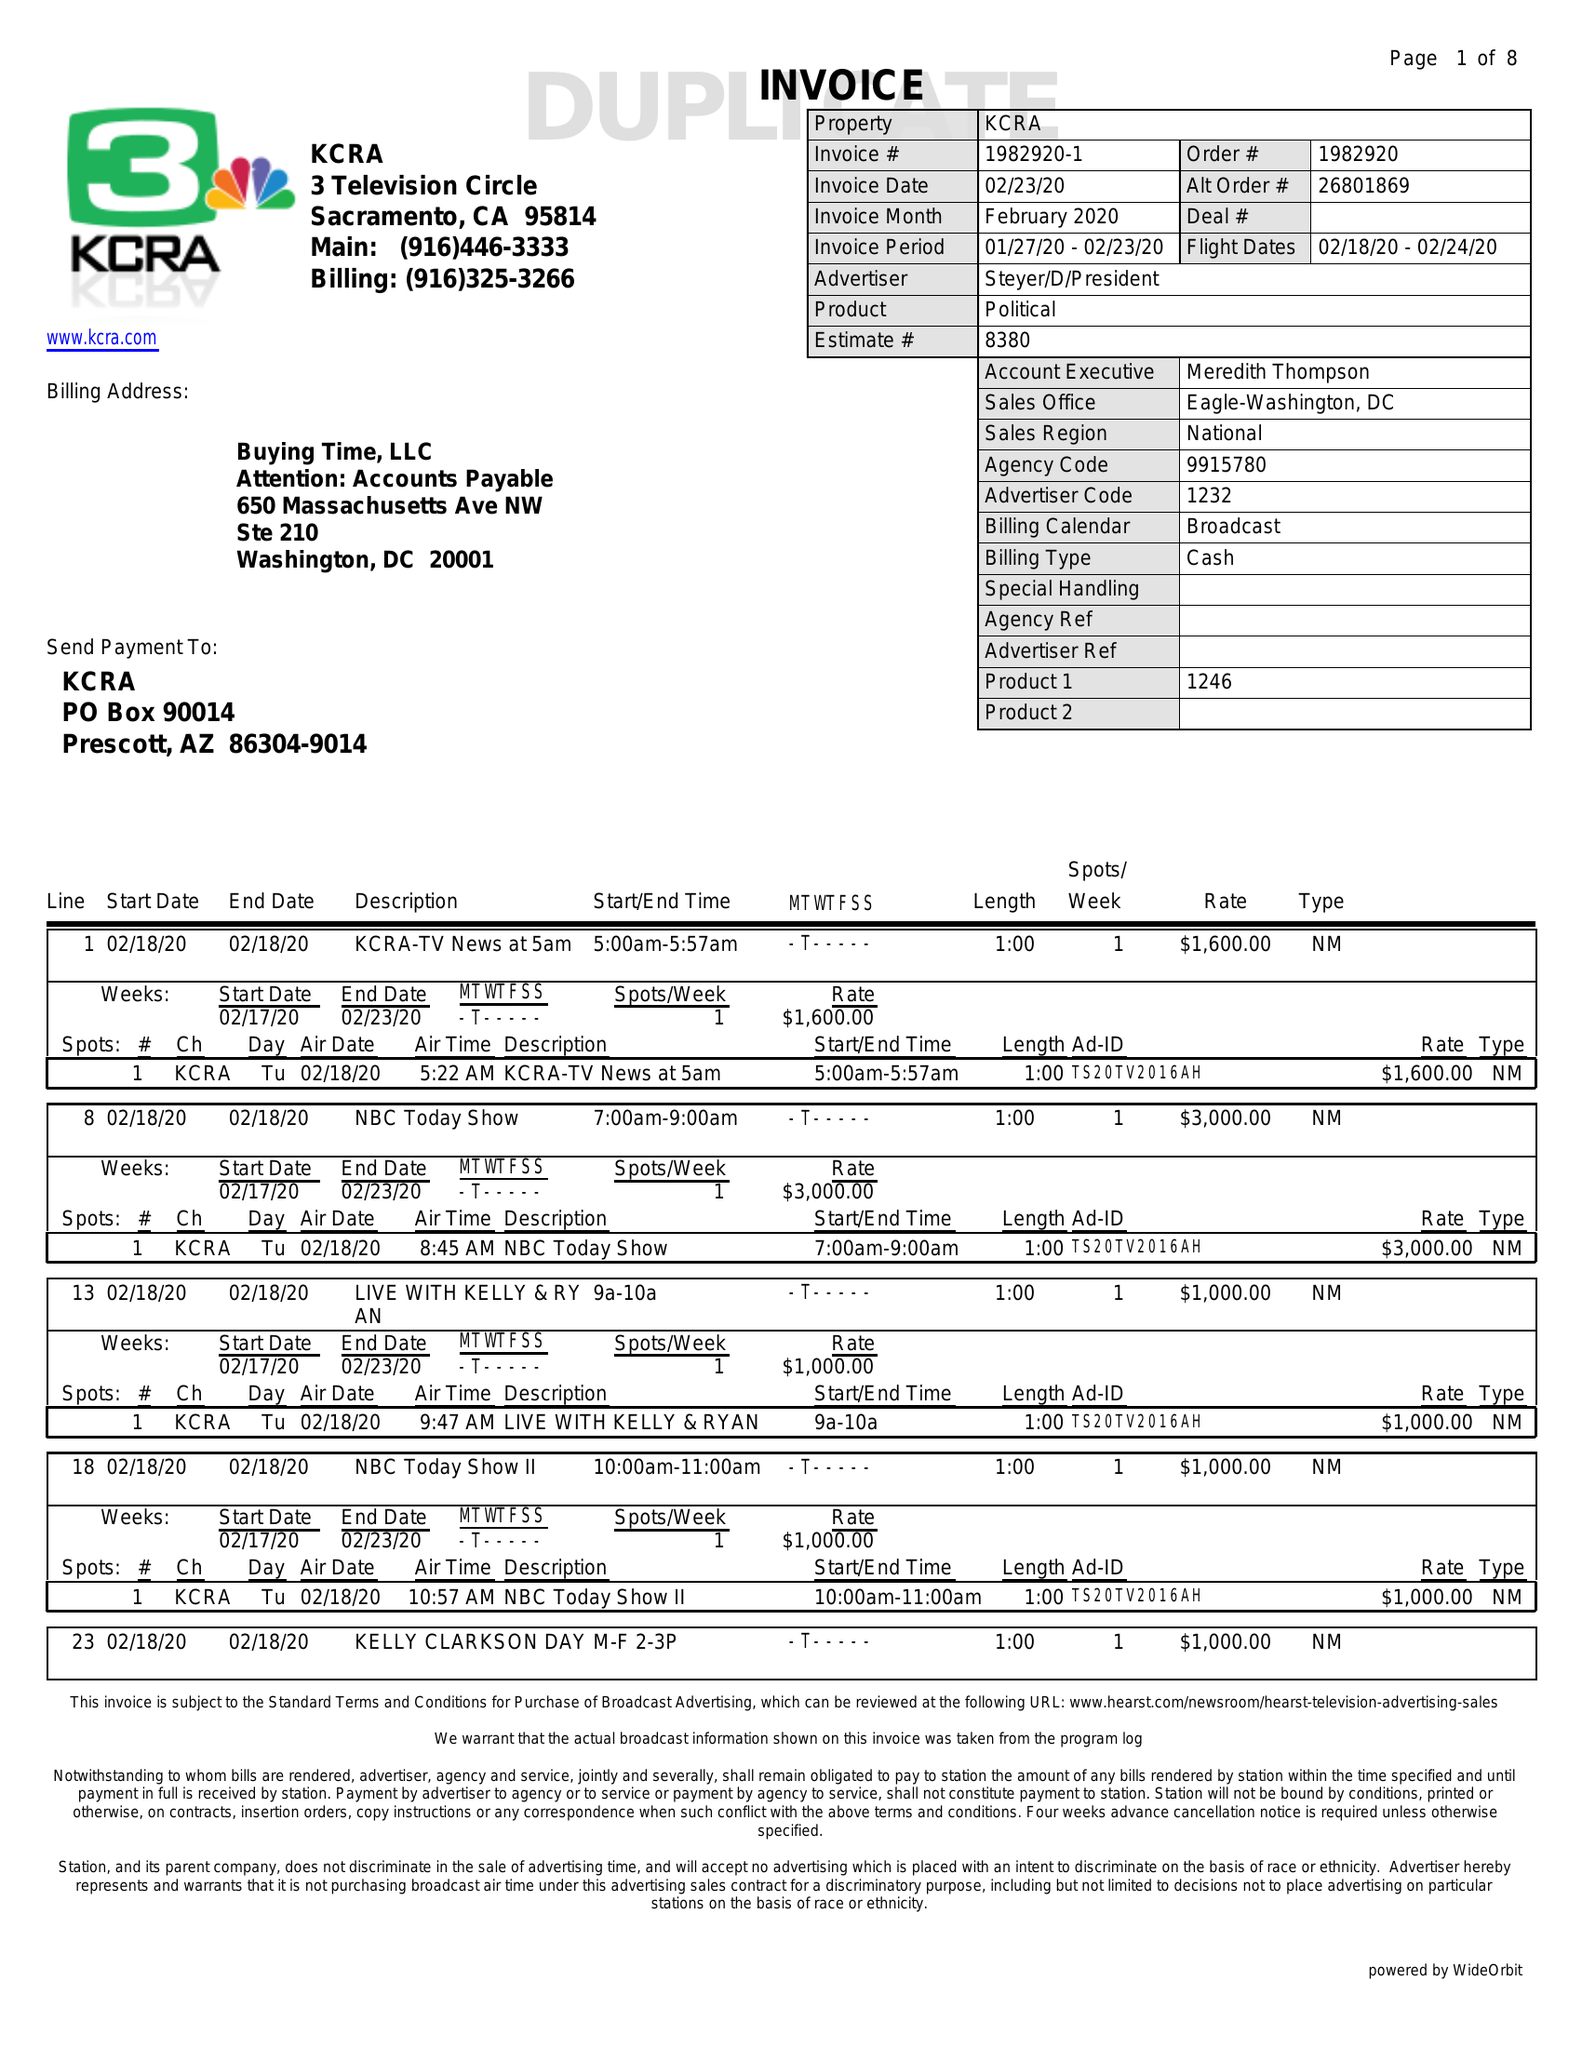What is the value for the advertiser?
Answer the question using a single word or phrase. STEYER/D/PRESIDENT 